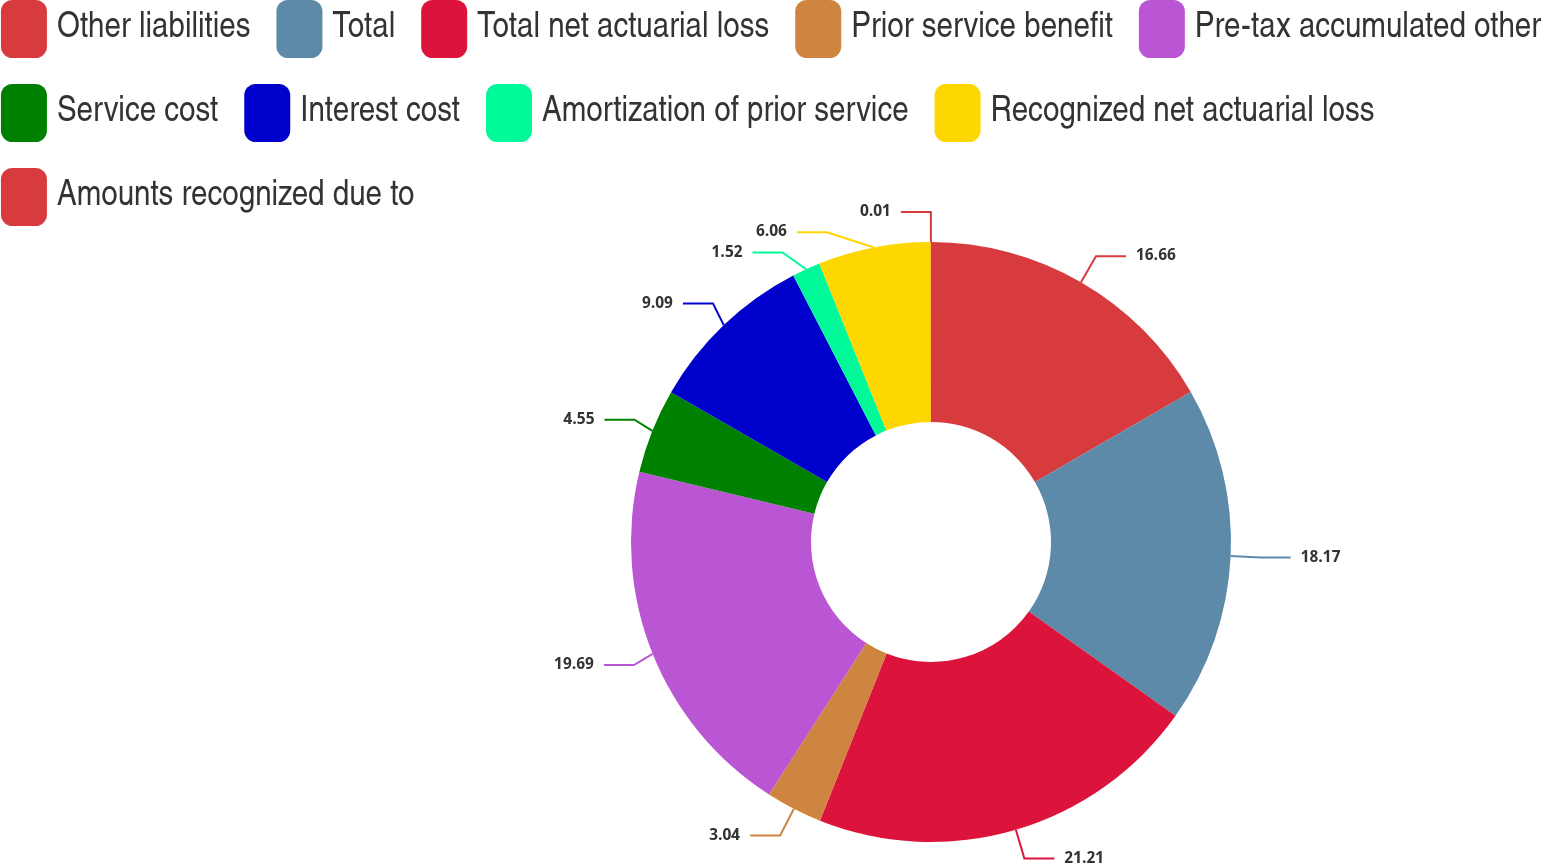Convert chart. <chart><loc_0><loc_0><loc_500><loc_500><pie_chart><fcel>Other liabilities<fcel>Total<fcel>Total net actuarial loss<fcel>Prior service benefit<fcel>Pre-tax accumulated other<fcel>Service cost<fcel>Interest cost<fcel>Amortization of prior service<fcel>Recognized net actuarial loss<fcel>Amounts recognized due to<nl><fcel>16.66%<fcel>18.17%<fcel>21.2%<fcel>3.04%<fcel>19.69%<fcel>4.55%<fcel>9.09%<fcel>1.52%<fcel>6.06%<fcel>0.01%<nl></chart> 